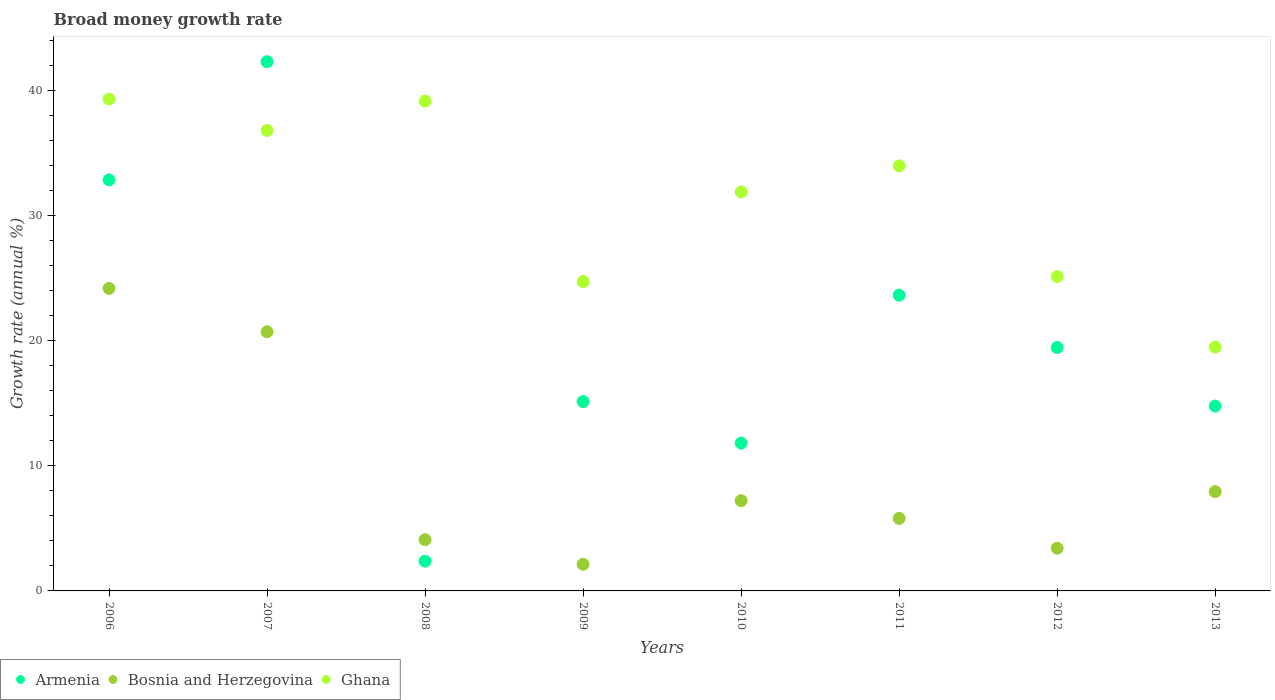How many different coloured dotlines are there?
Ensure brevity in your answer.  3. What is the growth rate in Ghana in 2010?
Your response must be concise. 31.92. Across all years, what is the maximum growth rate in Bosnia and Herzegovina?
Offer a very short reply. 24.2. Across all years, what is the minimum growth rate in Ghana?
Provide a short and direct response. 19.5. In which year was the growth rate in Armenia maximum?
Keep it short and to the point. 2007. What is the total growth rate in Bosnia and Herzegovina in the graph?
Make the answer very short. 75.53. What is the difference between the growth rate in Ghana in 2008 and that in 2013?
Your answer should be very brief. 19.68. What is the difference between the growth rate in Bosnia and Herzegovina in 2011 and the growth rate in Armenia in 2009?
Your answer should be very brief. -9.35. What is the average growth rate in Bosnia and Herzegovina per year?
Make the answer very short. 9.44. In the year 2010, what is the difference between the growth rate in Bosnia and Herzegovina and growth rate in Armenia?
Your response must be concise. -4.61. What is the ratio of the growth rate in Armenia in 2006 to that in 2013?
Offer a terse response. 2.22. Is the growth rate in Armenia in 2006 less than that in 2009?
Your response must be concise. No. What is the difference between the highest and the second highest growth rate in Bosnia and Herzegovina?
Make the answer very short. 3.47. What is the difference between the highest and the lowest growth rate in Bosnia and Herzegovina?
Ensure brevity in your answer.  22.07. Is the sum of the growth rate in Ghana in 2009 and 2011 greater than the maximum growth rate in Bosnia and Herzegovina across all years?
Your answer should be compact. Yes. Is it the case that in every year, the sum of the growth rate in Armenia and growth rate in Ghana  is greater than the growth rate in Bosnia and Herzegovina?
Your answer should be very brief. Yes. Is the growth rate in Armenia strictly greater than the growth rate in Bosnia and Herzegovina over the years?
Make the answer very short. No. How many years are there in the graph?
Offer a terse response. 8. What is the difference between two consecutive major ticks on the Y-axis?
Provide a succinct answer. 10. Where does the legend appear in the graph?
Ensure brevity in your answer.  Bottom left. How are the legend labels stacked?
Provide a succinct answer. Horizontal. What is the title of the graph?
Give a very brief answer. Broad money growth rate. Does "Grenada" appear as one of the legend labels in the graph?
Ensure brevity in your answer.  No. What is the label or title of the Y-axis?
Your answer should be compact. Growth rate (annual %). What is the Growth rate (annual %) of Armenia in 2006?
Provide a short and direct response. 32.88. What is the Growth rate (annual %) of Bosnia and Herzegovina in 2006?
Your answer should be very brief. 24.2. What is the Growth rate (annual %) of Ghana in 2006?
Give a very brief answer. 39.34. What is the Growth rate (annual %) in Armenia in 2007?
Provide a succinct answer. 42.33. What is the Growth rate (annual %) in Bosnia and Herzegovina in 2007?
Ensure brevity in your answer.  20.72. What is the Growth rate (annual %) in Ghana in 2007?
Offer a terse response. 36.83. What is the Growth rate (annual %) of Armenia in 2008?
Your answer should be very brief. 2.38. What is the Growth rate (annual %) of Bosnia and Herzegovina in 2008?
Your answer should be compact. 4.1. What is the Growth rate (annual %) in Ghana in 2008?
Give a very brief answer. 39.18. What is the Growth rate (annual %) in Armenia in 2009?
Your response must be concise. 15.15. What is the Growth rate (annual %) of Bosnia and Herzegovina in 2009?
Your response must be concise. 2.13. What is the Growth rate (annual %) of Ghana in 2009?
Give a very brief answer. 24.74. What is the Growth rate (annual %) of Armenia in 2010?
Keep it short and to the point. 11.83. What is the Growth rate (annual %) in Bosnia and Herzegovina in 2010?
Keep it short and to the point. 7.22. What is the Growth rate (annual %) in Ghana in 2010?
Make the answer very short. 31.92. What is the Growth rate (annual %) of Armenia in 2011?
Offer a terse response. 23.66. What is the Growth rate (annual %) in Bosnia and Herzegovina in 2011?
Your answer should be compact. 5.8. What is the Growth rate (annual %) of Ghana in 2011?
Keep it short and to the point. 33.99. What is the Growth rate (annual %) in Armenia in 2012?
Provide a short and direct response. 19.47. What is the Growth rate (annual %) of Bosnia and Herzegovina in 2012?
Provide a short and direct response. 3.41. What is the Growth rate (annual %) of Ghana in 2012?
Give a very brief answer. 25.14. What is the Growth rate (annual %) of Armenia in 2013?
Your answer should be compact. 14.78. What is the Growth rate (annual %) of Bosnia and Herzegovina in 2013?
Your response must be concise. 7.94. What is the Growth rate (annual %) in Ghana in 2013?
Your answer should be compact. 19.5. Across all years, what is the maximum Growth rate (annual %) of Armenia?
Provide a succinct answer. 42.33. Across all years, what is the maximum Growth rate (annual %) in Bosnia and Herzegovina?
Give a very brief answer. 24.2. Across all years, what is the maximum Growth rate (annual %) of Ghana?
Make the answer very short. 39.34. Across all years, what is the minimum Growth rate (annual %) of Armenia?
Give a very brief answer. 2.38. Across all years, what is the minimum Growth rate (annual %) of Bosnia and Herzegovina?
Ensure brevity in your answer.  2.13. Across all years, what is the minimum Growth rate (annual %) in Ghana?
Ensure brevity in your answer.  19.5. What is the total Growth rate (annual %) of Armenia in the graph?
Your response must be concise. 162.46. What is the total Growth rate (annual %) in Bosnia and Herzegovina in the graph?
Give a very brief answer. 75.53. What is the total Growth rate (annual %) of Ghana in the graph?
Your answer should be very brief. 250.64. What is the difference between the Growth rate (annual %) of Armenia in 2006 and that in 2007?
Make the answer very short. -9.45. What is the difference between the Growth rate (annual %) of Bosnia and Herzegovina in 2006 and that in 2007?
Provide a succinct answer. 3.47. What is the difference between the Growth rate (annual %) of Ghana in 2006 and that in 2007?
Your response must be concise. 2.51. What is the difference between the Growth rate (annual %) in Armenia in 2006 and that in 2008?
Your response must be concise. 30.5. What is the difference between the Growth rate (annual %) in Bosnia and Herzegovina in 2006 and that in 2008?
Your response must be concise. 20.1. What is the difference between the Growth rate (annual %) of Ghana in 2006 and that in 2008?
Offer a very short reply. 0.16. What is the difference between the Growth rate (annual %) of Armenia in 2006 and that in 2009?
Your response must be concise. 17.73. What is the difference between the Growth rate (annual %) of Bosnia and Herzegovina in 2006 and that in 2009?
Provide a succinct answer. 22.07. What is the difference between the Growth rate (annual %) of Ghana in 2006 and that in 2009?
Ensure brevity in your answer.  14.6. What is the difference between the Growth rate (annual %) in Armenia in 2006 and that in 2010?
Offer a very short reply. 21.05. What is the difference between the Growth rate (annual %) in Bosnia and Herzegovina in 2006 and that in 2010?
Your answer should be compact. 16.98. What is the difference between the Growth rate (annual %) in Ghana in 2006 and that in 2010?
Your answer should be very brief. 7.42. What is the difference between the Growth rate (annual %) in Armenia in 2006 and that in 2011?
Your response must be concise. 9.22. What is the difference between the Growth rate (annual %) in Bosnia and Herzegovina in 2006 and that in 2011?
Keep it short and to the point. 18.4. What is the difference between the Growth rate (annual %) of Ghana in 2006 and that in 2011?
Keep it short and to the point. 5.35. What is the difference between the Growth rate (annual %) of Armenia in 2006 and that in 2012?
Offer a terse response. 13.41. What is the difference between the Growth rate (annual %) of Bosnia and Herzegovina in 2006 and that in 2012?
Offer a terse response. 20.78. What is the difference between the Growth rate (annual %) in Ghana in 2006 and that in 2012?
Make the answer very short. 14.2. What is the difference between the Growth rate (annual %) in Armenia in 2006 and that in 2013?
Keep it short and to the point. 18.1. What is the difference between the Growth rate (annual %) of Bosnia and Herzegovina in 2006 and that in 2013?
Give a very brief answer. 16.26. What is the difference between the Growth rate (annual %) in Ghana in 2006 and that in 2013?
Ensure brevity in your answer.  19.84. What is the difference between the Growth rate (annual %) of Armenia in 2007 and that in 2008?
Your answer should be very brief. 39.95. What is the difference between the Growth rate (annual %) of Bosnia and Herzegovina in 2007 and that in 2008?
Your response must be concise. 16.62. What is the difference between the Growth rate (annual %) in Ghana in 2007 and that in 2008?
Your response must be concise. -2.34. What is the difference between the Growth rate (annual %) of Armenia in 2007 and that in 2009?
Offer a very short reply. 27.18. What is the difference between the Growth rate (annual %) of Bosnia and Herzegovina in 2007 and that in 2009?
Offer a terse response. 18.59. What is the difference between the Growth rate (annual %) of Ghana in 2007 and that in 2009?
Provide a succinct answer. 12.1. What is the difference between the Growth rate (annual %) of Armenia in 2007 and that in 2010?
Keep it short and to the point. 30.5. What is the difference between the Growth rate (annual %) in Bosnia and Herzegovina in 2007 and that in 2010?
Your answer should be compact. 13.51. What is the difference between the Growth rate (annual %) of Ghana in 2007 and that in 2010?
Provide a succinct answer. 4.92. What is the difference between the Growth rate (annual %) in Armenia in 2007 and that in 2011?
Your answer should be compact. 18.67. What is the difference between the Growth rate (annual %) of Bosnia and Herzegovina in 2007 and that in 2011?
Offer a terse response. 14.93. What is the difference between the Growth rate (annual %) in Ghana in 2007 and that in 2011?
Offer a terse response. 2.84. What is the difference between the Growth rate (annual %) of Armenia in 2007 and that in 2012?
Offer a very short reply. 22.86. What is the difference between the Growth rate (annual %) of Bosnia and Herzegovina in 2007 and that in 2012?
Make the answer very short. 17.31. What is the difference between the Growth rate (annual %) in Ghana in 2007 and that in 2012?
Provide a succinct answer. 11.7. What is the difference between the Growth rate (annual %) of Armenia in 2007 and that in 2013?
Provide a succinct answer. 27.55. What is the difference between the Growth rate (annual %) of Bosnia and Herzegovina in 2007 and that in 2013?
Offer a terse response. 12.78. What is the difference between the Growth rate (annual %) of Ghana in 2007 and that in 2013?
Offer a terse response. 17.33. What is the difference between the Growth rate (annual %) of Armenia in 2008 and that in 2009?
Your answer should be compact. -12.77. What is the difference between the Growth rate (annual %) of Bosnia and Herzegovina in 2008 and that in 2009?
Provide a short and direct response. 1.97. What is the difference between the Growth rate (annual %) in Ghana in 2008 and that in 2009?
Give a very brief answer. 14.44. What is the difference between the Growth rate (annual %) in Armenia in 2008 and that in 2010?
Ensure brevity in your answer.  -9.45. What is the difference between the Growth rate (annual %) of Bosnia and Herzegovina in 2008 and that in 2010?
Your response must be concise. -3.12. What is the difference between the Growth rate (annual %) of Ghana in 2008 and that in 2010?
Make the answer very short. 7.26. What is the difference between the Growth rate (annual %) of Armenia in 2008 and that in 2011?
Your answer should be very brief. -21.28. What is the difference between the Growth rate (annual %) of Bosnia and Herzegovina in 2008 and that in 2011?
Your response must be concise. -1.7. What is the difference between the Growth rate (annual %) in Ghana in 2008 and that in 2011?
Your answer should be compact. 5.18. What is the difference between the Growth rate (annual %) of Armenia in 2008 and that in 2012?
Offer a terse response. -17.09. What is the difference between the Growth rate (annual %) of Bosnia and Herzegovina in 2008 and that in 2012?
Your response must be concise. 0.69. What is the difference between the Growth rate (annual %) of Ghana in 2008 and that in 2012?
Offer a terse response. 14.04. What is the difference between the Growth rate (annual %) in Armenia in 2008 and that in 2013?
Offer a very short reply. -12.4. What is the difference between the Growth rate (annual %) of Bosnia and Herzegovina in 2008 and that in 2013?
Provide a short and direct response. -3.84. What is the difference between the Growth rate (annual %) of Ghana in 2008 and that in 2013?
Keep it short and to the point. 19.68. What is the difference between the Growth rate (annual %) of Armenia in 2009 and that in 2010?
Keep it short and to the point. 3.32. What is the difference between the Growth rate (annual %) of Bosnia and Herzegovina in 2009 and that in 2010?
Provide a succinct answer. -5.09. What is the difference between the Growth rate (annual %) in Ghana in 2009 and that in 2010?
Make the answer very short. -7.18. What is the difference between the Growth rate (annual %) in Armenia in 2009 and that in 2011?
Your answer should be very brief. -8.51. What is the difference between the Growth rate (annual %) of Bosnia and Herzegovina in 2009 and that in 2011?
Offer a terse response. -3.67. What is the difference between the Growth rate (annual %) of Ghana in 2009 and that in 2011?
Provide a succinct answer. -9.26. What is the difference between the Growth rate (annual %) of Armenia in 2009 and that in 2012?
Keep it short and to the point. -4.32. What is the difference between the Growth rate (annual %) of Bosnia and Herzegovina in 2009 and that in 2012?
Offer a very short reply. -1.28. What is the difference between the Growth rate (annual %) of Ghana in 2009 and that in 2012?
Give a very brief answer. -0.4. What is the difference between the Growth rate (annual %) of Armenia in 2009 and that in 2013?
Your answer should be very brief. 0.36. What is the difference between the Growth rate (annual %) of Bosnia and Herzegovina in 2009 and that in 2013?
Provide a succinct answer. -5.81. What is the difference between the Growth rate (annual %) of Ghana in 2009 and that in 2013?
Your response must be concise. 5.24. What is the difference between the Growth rate (annual %) of Armenia in 2010 and that in 2011?
Keep it short and to the point. -11.83. What is the difference between the Growth rate (annual %) of Bosnia and Herzegovina in 2010 and that in 2011?
Provide a succinct answer. 1.42. What is the difference between the Growth rate (annual %) in Ghana in 2010 and that in 2011?
Give a very brief answer. -2.08. What is the difference between the Growth rate (annual %) of Armenia in 2010 and that in 2012?
Your answer should be very brief. -7.64. What is the difference between the Growth rate (annual %) in Bosnia and Herzegovina in 2010 and that in 2012?
Your response must be concise. 3.8. What is the difference between the Growth rate (annual %) of Ghana in 2010 and that in 2012?
Offer a terse response. 6.78. What is the difference between the Growth rate (annual %) in Armenia in 2010 and that in 2013?
Give a very brief answer. -2.95. What is the difference between the Growth rate (annual %) of Bosnia and Herzegovina in 2010 and that in 2013?
Your answer should be compact. -0.72. What is the difference between the Growth rate (annual %) of Ghana in 2010 and that in 2013?
Provide a short and direct response. 12.42. What is the difference between the Growth rate (annual %) in Armenia in 2011 and that in 2012?
Your answer should be compact. 4.19. What is the difference between the Growth rate (annual %) in Bosnia and Herzegovina in 2011 and that in 2012?
Ensure brevity in your answer.  2.38. What is the difference between the Growth rate (annual %) of Ghana in 2011 and that in 2012?
Your answer should be very brief. 8.86. What is the difference between the Growth rate (annual %) of Armenia in 2011 and that in 2013?
Your answer should be compact. 8.87. What is the difference between the Growth rate (annual %) in Bosnia and Herzegovina in 2011 and that in 2013?
Provide a succinct answer. -2.14. What is the difference between the Growth rate (annual %) of Ghana in 2011 and that in 2013?
Offer a very short reply. 14.49. What is the difference between the Growth rate (annual %) in Armenia in 2012 and that in 2013?
Your answer should be very brief. 4.69. What is the difference between the Growth rate (annual %) of Bosnia and Herzegovina in 2012 and that in 2013?
Offer a terse response. -4.53. What is the difference between the Growth rate (annual %) of Ghana in 2012 and that in 2013?
Provide a succinct answer. 5.64. What is the difference between the Growth rate (annual %) in Armenia in 2006 and the Growth rate (annual %) in Bosnia and Herzegovina in 2007?
Your answer should be compact. 12.15. What is the difference between the Growth rate (annual %) of Armenia in 2006 and the Growth rate (annual %) of Ghana in 2007?
Keep it short and to the point. -3.96. What is the difference between the Growth rate (annual %) in Bosnia and Herzegovina in 2006 and the Growth rate (annual %) in Ghana in 2007?
Your answer should be very brief. -12.64. What is the difference between the Growth rate (annual %) in Armenia in 2006 and the Growth rate (annual %) in Bosnia and Herzegovina in 2008?
Your answer should be compact. 28.78. What is the difference between the Growth rate (annual %) of Armenia in 2006 and the Growth rate (annual %) of Ghana in 2008?
Offer a terse response. -6.3. What is the difference between the Growth rate (annual %) in Bosnia and Herzegovina in 2006 and the Growth rate (annual %) in Ghana in 2008?
Your answer should be compact. -14.98. What is the difference between the Growth rate (annual %) in Armenia in 2006 and the Growth rate (annual %) in Bosnia and Herzegovina in 2009?
Keep it short and to the point. 30.75. What is the difference between the Growth rate (annual %) of Armenia in 2006 and the Growth rate (annual %) of Ghana in 2009?
Give a very brief answer. 8.14. What is the difference between the Growth rate (annual %) in Bosnia and Herzegovina in 2006 and the Growth rate (annual %) in Ghana in 2009?
Keep it short and to the point. -0.54. What is the difference between the Growth rate (annual %) of Armenia in 2006 and the Growth rate (annual %) of Bosnia and Herzegovina in 2010?
Your answer should be very brief. 25.66. What is the difference between the Growth rate (annual %) of Armenia in 2006 and the Growth rate (annual %) of Ghana in 2010?
Give a very brief answer. 0.96. What is the difference between the Growth rate (annual %) of Bosnia and Herzegovina in 2006 and the Growth rate (annual %) of Ghana in 2010?
Provide a succinct answer. -7.72. What is the difference between the Growth rate (annual %) of Armenia in 2006 and the Growth rate (annual %) of Bosnia and Herzegovina in 2011?
Your answer should be compact. 27.08. What is the difference between the Growth rate (annual %) of Armenia in 2006 and the Growth rate (annual %) of Ghana in 2011?
Keep it short and to the point. -1.12. What is the difference between the Growth rate (annual %) of Bosnia and Herzegovina in 2006 and the Growth rate (annual %) of Ghana in 2011?
Give a very brief answer. -9.8. What is the difference between the Growth rate (annual %) of Armenia in 2006 and the Growth rate (annual %) of Bosnia and Herzegovina in 2012?
Give a very brief answer. 29.46. What is the difference between the Growth rate (annual %) in Armenia in 2006 and the Growth rate (annual %) in Ghana in 2012?
Provide a succinct answer. 7.74. What is the difference between the Growth rate (annual %) in Bosnia and Herzegovina in 2006 and the Growth rate (annual %) in Ghana in 2012?
Make the answer very short. -0.94. What is the difference between the Growth rate (annual %) in Armenia in 2006 and the Growth rate (annual %) in Bosnia and Herzegovina in 2013?
Your answer should be compact. 24.94. What is the difference between the Growth rate (annual %) in Armenia in 2006 and the Growth rate (annual %) in Ghana in 2013?
Provide a short and direct response. 13.38. What is the difference between the Growth rate (annual %) in Bosnia and Herzegovina in 2006 and the Growth rate (annual %) in Ghana in 2013?
Offer a very short reply. 4.7. What is the difference between the Growth rate (annual %) of Armenia in 2007 and the Growth rate (annual %) of Bosnia and Herzegovina in 2008?
Your answer should be compact. 38.23. What is the difference between the Growth rate (annual %) in Armenia in 2007 and the Growth rate (annual %) in Ghana in 2008?
Offer a very short reply. 3.15. What is the difference between the Growth rate (annual %) in Bosnia and Herzegovina in 2007 and the Growth rate (annual %) in Ghana in 2008?
Your response must be concise. -18.45. What is the difference between the Growth rate (annual %) of Armenia in 2007 and the Growth rate (annual %) of Bosnia and Herzegovina in 2009?
Your response must be concise. 40.2. What is the difference between the Growth rate (annual %) in Armenia in 2007 and the Growth rate (annual %) in Ghana in 2009?
Offer a very short reply. 17.59. What is the difference between the Growth rate (annual %) of Bosnia and Herzegovina in 2007 and the Growth rate (annual %) of Ghana in 2009?
Your answer should be compact. -4.01. What is the difference between the Growth rate (annual %) in Armenia in 2007 and the Growth rate (annual %) in Bosnia and Herzegovina in 2010?
Keep it short and to the point. 35.11. What is the difference between the Growth rate (annual %) of Armenia in 2007 and the Growth rate (annual %) of Ghana in 2010?
Your response must be concise. 10.41. What is the difference between the Growth rate (annual %) of Bosnia and Herzegovina in 2007 and the Growth rate (annual %) of Ghana in 2010?
Your answer should be compact. -11.19. What is the difference between the Growth rate (annual %) in Armenia in 2007 and the Growth rate (annual %) in Bosnia and Herzegovina in 2011?
Offer a very short reply. 36.53. What is the difference between the Growth rate (annual %) in Armenia in 2007 and the Growth rate (annual %) in Ghana in 2011?
Provide a short and direct response. 8.33. What is the difference between the Growth rate (annual %) of Bosnia and Herzegovina in 2007 and the Growth rate (annual %) of Ghana in 2011?
Offer a terse response. -13.27. What is the difference between the Growth rate (annual %) in Armenia in 2007 and the Growth rate (annual %) in Bosnia and Herzegovina in 2012?
Ensure brevity in your answer.  38.91. What is the difference between the Growth rate (annual %) in Armenia in 2007 and the Growth rate (annual %) in Ghana in 2012?
Keep it short and to the point. 17.19. What is the difference between the Growth rate (annual %) in Bosnia and Herzegovina in 2007 and the Growth rate (annual %) in Ghana in 2012?
Provide a short and direct response. -4.41. What is the difference between the Growth rate (annual %) in Armenia in 2007 and the Growth rate (annual %) in Bosnia and Herzegovina in 2013?
Your answer should be compact. 34.39. What is the difference between the Growth rate (annual %) of Armenia in 2007 and the Growth rate (annual %) of Ghana in 2013?
Provide a short and direct response. 22.83. What is the difference between the Growth rate (annual %) of Bosnia and Herzegovina in 2007 and the Growth rate (annual %) of Ghana in 2013?
Provide a succinct answer. 1.22. What is the difference between the Growth rate (annual %) of Armenia in 2008 and the Growth rate (annual %) of Bosnia and Herzegovina in 2009?
Make the answer very short. 0.25. What is the difference between the Growth rate (annual %) of Armenia in 2008 and the Growth rate (annual %) of Ghana in 2009?
Give a very brief answer. -22.36. What is the difference between the Growth rate (annual %) in Bosnia and Herzegovina in 2008 and the Growth rate (annual %) in Ghana in 2009?
Give a very brief answer. -20.64. What is the difference between the Growth rate (annual %) in Armenia in 2008 and the Growth rate (annual %) in Bosnia and Herzegovina in 2010?
Your response must be concise. -4.84. What is the difference between the Growth rate (annual %) of Armenia in 2008 and the Growth rate (annual %) of Ghana in 2010?
Keep it short and to the point. -29.54. What is the difference between the Growth rate (annual %) in Bosnia and Herzegovina in 2008 and the Growth rate (annual %) in Ghana in 2010?
Your response must be concise. -27.82. What is the difference between the Growth rate (annual %) of Armenia in 2008 and the Growth rate (annual %) of Bosnia and Herzegovina in 2011?
Offer a terse response. -3.42. What is the difference between the Growth rate (annual %) of Armenia in 2008 and the Growth rate (annual %) of Ghana in 2011?
Give a very brief answer. -31.62. What is the difference between the Growth rate (annual %) in Bosnia and Herzegovina in 2008 and the Growth rate (annual %) in Ghana in 2011?
Provide a succinct answer. -29.89. What is the difference between the Growth rate (annual %) of Armenia in 2008 and the Growth rate (annual %) of Bosnia and Herzegovina in 2012?
Your response must be concise. -1.04. What is the difference between the Growth rate (annual %) in Armenia in 2008 and the Growth rate (annual %) in Ghana in 2012?
Your response must be concise. -22.76. What is the difference between the Growth rate (annual %) of Bosnia and Herzegovina in 2008 and the Growth rate (annual %) of Ghana in 2012?
Ensure brevity in your answer.  -21.04. What is the difference between the Growth rate (annual %) of Armenia in 2008 and the Growth rate (annual %) of Bosnia and Herzegovina in 2013?
Your answer should be compact. -5.56. What is the difference between the Growth rate (annual %) of Armenia in 2008 and the Growth rate (annual %) of Ghana in 2013?
Provide a succinct answer. -17.12. What is the difference between the Growth rate (annual %) of Bosnia and Herzegovina in 2008 and the Growth rate (annual %) of Ghana in 2013?
Provide a succinct answer. -15.4. What is the difference between the Growth rate (annual %) in Armenia in 2009 and the Growth rate (annual %) in Bosnia and Herzegovina in 2010?
Provide a succinct answer. 7.93. What is the difference between the Growth rate (annual %) of Armenia in 2009 and the Growth rate (annual %) of Ghana in 2010?
Provide a short and direct response. -16.77. What is the difference between the Growth rate (annual %) in Bosnia and Herzegovina in 2009 and the Growth rate (annual %) in Ghana in 2010?
Your answer should be compact. -29.79. What is the difference between the Growth rate (annual %) in Armenia in 2009 and the Growth rate (annual %) in Bosnia and Herzegovina in 2011?
Provide a succinct answer. 9.35. What is the difference between the Growth rate (annual %) in Armenia in 2009 and the Growth rate (annual %) in Ghana in 2011?
Make the answer very short. -18.85. What is the difference between the Growth rate (annual %) of Bosnia and Herzegovina in 2009 and the Growth rate (annual %) of Ghana in 2011?
Your answer should be compact. -31.86. What is the difference between the Growth rate (annual %) in Armenia in 2009 and the Growth rate (annual %) in Bosnia and Herzegovina in 2012?
Offer a very short reply. 11.73. What is the difference between the Growth rate (annual %) of Armenia in 2009 and the Growth rate (annual %) of Ghana in 2012?
Your response must be concise. -9.99. What is the difference between the Growth rate (annual %) in Bosnia and Herzegovina in 2009 and the Growth rate (annual %) in Ghana in 2012?
Give a very brief answer. -23.01. What is the difference between the Growth rate (annual %) in Armenia in 2009 and the Growth rate (annual %) in Bosnia and Herzegovina in 2013?
Provide a short and direct response. 7.21. What is the difference between the Growth rate (annual %) of Armenia in 2009 and the Growth rate (annual %) of Ghana in 2013?
Make the answer very short. -4.35. What is the difference between the Growth rate (annual %) in Bosnia and Herzegovina in 2009 and the Growth rate (annual %) in Ghana in 2013?
Offer a terse response. -17.37. What is the difference between the Growth rate (annual %) of Armenia in 2010 and the Growth rate (annual %) of Bosnia and Herzegovina in 2011?
Your response must be concise. 6.03. What is the difference between the Growth rate (annual %) of Armenia in 2010 and the Growth rate (annual %) of Ghana in 2011?
Your answer should be very brief. -22.17. What is the difference between the Growth rate (annual %) of Bosnia and Herzegovina in 2010 and the Growth rate (annual %) of Ghana in 2011?
Your response must be concise. -26.78. What is the difference between the Growth rate (annual %) of Armenia in 2010 and the Growth rate (annual %) of Bosnia and Herzegovina in 2012?
Give a very brief answer. 8.41. What is the difference between the Growth rate (annual %) of Armenia in 2010 and the Growth rate (annual %) of Ghana in 2012?
Provide a succinct answer. -13.31. What is the difference between the Growth rate (annual %) of Bosnia and Herzegovina in 2010 and the Growth rate (annual %) of Ghana in 2012?
Give a very brief answer. -17.92. What is the difference between the Growth rate (annual %) in Armenia in 2010 and the Growth rate (annual %) in Bosnia and Herzegovina in 2013?
Keep it short and to the point. 3.89. What is the difference between the Growth rate (annual %) in Armenia in 2010 and the Growth rate (annual %) in Ghana in 2013?
Keep it short and to the point. -7.67. What is the difference between the Growth rate (annual %) of Bosnia and Herzegovina in 2010 and the Growth rate (annual %) of Ghana in 2013?
Keep it short and to the point. -12.28. What is the difference between the Growth rate (annual %) of Armenia in 2011 and the Growth rate (annual %) of Bosnia and Herzegovina in 2012?
Ensure brevity in your answer.  20.24. What is the difference between the Growth rate (annual %) in Armenia in 2011 and the Growth rate (annual %) in Ghana in 2012?
Offer a terse response. -1.48. What is the difference between the Growth rate (annual %) of Bosnia and Herzegovina in 2011 and the Growth rate (annual %) of Ghana in 2012?
Offer a terse response. -19.34. What is the difference between the Growth rate (annual %) in Armenia in 2011 and the Growth rate (annual %) in Bosnia and Herzegovina in 2013?
Offer a very short reply. 15.72. What is the difference between the Growth rate (annual %) in Armenia in 2011 and the Growth rate (annual %) in Ghana in 2013?
Provide a short and direct response. 4.15. What is the difference between the Growth rate (annual %) of Bosnia and Herzegovina in 2011 and the Growth rate (annual %) of Ghana in 2013?
Ensure brevity in your answer.  -13.7. What is the difference between the Growth rate (annual %) of Armenia in 2012 and the Growth rate (annual %) of Bosnia and Herzegovina in 2013?
Provide a short and direct response. 11.53. What is the difference between the Growth rate (annual %) in Armenia in 2012 and the Growth rate (annual %) in Ghana in 2013?
Your response must be concise. -0.03. What is the difference between the Growth rate (annual %) of Bosnia and Herzegovina in 2012 and the Growth rate (annual %) of Ghana in 2013?
Your answer should be very brief. -16.09. What is the average Growth rate (annual %) in Armenia per year?
Provide a short and direct response. 20.31. What is the average Growth rate (annual %) of Bosnia and Herzegovina per year?
Offer a terse response. 9.44. What is the average Growth rate (annual %) in Ghana per year?
Keep it short and to the point. 31.33. In the year 2006, what is the difference between the Growth rate (annual %) of Armenia and Growth rate (annual %) of Bosnia and Herzegovina?
Your response must be concise. 8.68. In the year 2006, what is the difference between the Growth rate (annual %) in Armenia and Growth rate (annual %) in Ghana?
Offer a very short reply. -6.46. In the year 2006, what is the difference between the Growth rate (annual %) in Bosnia and Herzegovina and Growth rate (annual %) in Ghana?
Make the answer very short. -15.14. In the year 2007, what is the difference between the Growth rate (annual %) of Armenia and Growth rate (annual %) of Bosnia and Herzegovina?
Your response must be concise. 21.6. In the year 2007, what is the difference between the Growth rate (annual %) in Armenia and Growth rate (annual %) in Ghana?
Offer a very short reply. 5.49. In the year 2007, what is the difference between the Growth rate (annual %) of Bosnia and Herzegovina and Growth rate (annual %) of Ghana?
Provide a succinct answer. -16.11. In the year 2008, what is the difference between the Growth rate (annual %) in Armenia and Growth rate (annual %) in Bosnia and Herzegovina?
Your answer should be compact. -1.72. In the year 2008, what is the difference between the Growth rate (annual %) in Armenia and Growth rate (annual %) in Ghana?
Offer a very short reply. -36.8. In the year 2008, what is the difference between the Growth rate (annual %) in Bosnia and Herzegovina and Growth rate (annual %) in Ghana?
Give a very brief answer. -35.08. In the year 2009, what is the difference between the Growth rate (annual %) in Armenia and Growth rate (annual %) in Bosnia and Herzegovina?
Provide a short and direct response. 13.01. In the year 2009, what is the difference between the Growth rate (annual %) in Armenia and Growth rate (annual %) in Ghana?
Your answer should be compact. -9.59. In the year 2009, what is the difference between the Growth rate (annual %) of Bosnia and Herzegovina and Growth rate (annual %) of Ghana?
Provide a short and direct response. -22.61. In the year 2010, what is the difference between the Growth rate (annual %) of Armenia and Growth rate (annual %) of Bosnia and Herzegovina?
Your response must be concise. 4.61. In the year 2010, what is the difference between the Growth rate (annual %) in Armenia and Growth rate (annual %) in Ghana?
Your response must be concise. -20.09. In the year 2010, what is the difference between the Growth rate (annual %) in Bosnia and Herzegovina and Growth rate (annual %) in Ghana?
Provide a short and direct response. -24.7. In the year 2011, what is the difference between the Growth rate (annual %) of Armenia and Growth rate (annual %) of Bosnia and Herzegovina?
Keep it short and to the point. 17.86. In the year 2011, what is the difference between the Growth rate (annual %) of Armenia and Growth rate (annual %) of Ghana?
Provide a short and direct response. -10.34. In the year 2011, what is the difference between the Growth rate (annual %) in Bosnia and Herzegovina and Growth rate (annual %) in Ghana?
Give a very brief answer. -28.2. In the year 2012, what is the difference between the Growth rate (annual %) in Armenia and Growth rate (annual %) in Bosnia and Herzegovina?
Provide a short and direct response. 16.05. In the year 2012, what is the difference between the Growth rate (annual %) of Armenia and Growth rate (annual %) of Ghana?
Offer a terse response. -5.67. In the year 2012, what is the difference between the Growth rate (annual %) in Bosnia and Herzegovina and Growth rate (annual %) in Ghana?
Ensure brevity in your answer.  -21.72. In the year 2013, what is the difference between the Growth rate (annual %) in Armenia and Growth rate (annual %) in Bosnia and Herzegovina?
Give a very brief answer. 6.84. In the year 2013, what is the difference between the Growth rate (annual %) in Armenia and Growth rate (annual %) in Ghana?
Provide a succinct answer. -4.72. In the year 2013, what is the difference between the Growth rate (annual %) of Bosnia and Herzegovina and Growth rate (annual %) of Ghana?
Offer a very short reply. -11.56. What is the ratio of the Growth rate (annual %) in Armenia in 2006 to that in 2007?
Your answer should be very brief. 0.78. What is the ratio of the Growth rate (annual %) of Bosnia and Herzegovina in 2006 to that in 2007?
Offer a terse response. 1.17. What is the ratio of the Growth rate (annual %) in Ghana in 2006 to that in 2007?
Offer a very short reply. 1.07. What is the ratio of the Growth rate (annual %) of Armenia in 2006 to that in 2008?
Offer a terse response. 13.82. What is the ratio of the Growth rate (annual %) in Bosnia and Herzegovina in 2006 to that in 2008?
Offer a terse response. 5.9. What is the ratio of the Growth rate (annual %) in Ghana in 2006 to that in 2008?
Your answer should be compact. 1. What is the ratio of the Growth rate (annual %) in Armenia in 2006 to that in 2009?
Your answer should be very brief. 2.17. What is the ratio of the Growth rate (annual %) of Bosnia and Herzegovina in 2006 to that in 2009?
Your answer should be very brief. 11.35. What is the ratio of the Growth rate (annual %) of Ghana in 2006 to that in 2009?
Give a very brief answer. 1.59. What is the ratio of the Growth rate (annual %) in Armenia in 2006 to that in 2010?
Offer a terse response. 2.78. What is the ratio of the Growth rate (annual %) of Bosnia and Herzegovina in 2006 to that in 2010?
Provide a succinct answer. 3.35. What is the ratio of the Growth rate (annual %) in Ghana in 2006 to that in 2010?
Offer a terse response. 1.23. What is the ratio of the Growth rate (annual %) in Armenia in 2006 to that in 2011?
Provide a succinct answer. 1.39. What is the ratio of the Growth rate (annual %) in Bosnia and Herzegovina in 2006 to that in 2011?
Offer a terse response. 4.17. What is the ratio of the Growth rate (annual %) in Ghana in 2006 to that in 2011?
Your response must be concise. 1.16. What is the ratio of the Growth rate (annual %) in Armenia in 2006 to that in 2012?
Provide a succinct answer. 1.69. What is the ratio of the Growth rate (annual %) of Bosnia and Herzegovina in 2006 to that in 2012?
Offer a terse response. 7.09. What is the ratio of the Growth rate (annual %) in Ghana in 2006 to that in 2012?
Keep it short and to the point. 1.56. What is the ratio of the Growth rate (annual %) in Armenia in 2006 to that in 2013?
Offer a terse response. 2.22. What is the ratio of the Growth rate (annual %) in Bosnia and Herzegovina in 2006 to that in 2013?
Give a very brief answer. 3.05. What is the ratio of the Growth rate (annual %) of Ghana in 2006 to that in 2013?
Your response must be concise. 2.02. What is the ratio of the Growth rate (annual %) of Armenia in 2007 to that in 2008?
Give a very brief answer. 17.8. What is the ratio of the Growth rate (annual %) in Bosnia and Herzegovina in 2007 to that in 2008?
Your response must be concise. 5.05. What is the ratio of the Growth rate (annual %) of Ghana in 2007 to that in 2008?
Keep it short and to the point. 0.94. What is the ratio of the Growth rate (annual %) in Armenia in 2007 to that in 2009?
Make the answer very short. 2.79. What is the ratio of the Growth rate (annual %) of Bosnia and Herzegovina in 2007 to that in 2009?
Give a very brief answer. 9.72. What is the ratio of the Growth rate (annual %) of Ghana in 2007 to that in 2009?
Make the answer very short. 1.49. What is the ratio of the Growth rate (annual %) in Armenia in 2007 to that in 2010?
Provide a short and direct response. 3.58. What is the ratio of the Growth rate (annual %) in Bosnia and Herzegovina in 2007 to that in 2010?
Ensure brevity in your answer.  2.87. What is the ratio of the Growth rate (annual %) of Ghana in 2007 to that in 2010?
Your response must be concise. 1.15. What is the ratio of the Growth rate (annual %) of Armenia in 2007 to that in 2011?
Make the answer very short. 1.79. What is the ratio of the Growth rate (annual %) of Bosnia and Herzegovina in 2007 to that in 2011?
Offer a very short reply. 3.57. What is the ratio of the Growth rate (annual %) in Ghana in 2007 to that in 2011?
Keep it short and to the point. 1.08. What is the ratio of the Growth rate (annual %) of Armenia in 2007 to that in 2012?
Give a very brief answer. 2.17. What is the ratio of the Growth rate (annual %) in Bosnia and Herzegovina in 2007 to that in 2012?
Give a very brief answer. 6.07. What is the ratio of the Growth rate (annual %) in Ghana in 2007 to that in 2012?
Ensure brevity in your answer.  1.47. What is the ratio of the Growth rate (annual %) of Armenia in 2007 to that in 2013?
Your response must be concise. 2.86. What is the ratio of the Growth rate (annual %) of Bosnia and Herzegovina in 2007 to that in 2013?
Your answer should be very brief. 2.61. What is the ratio of the Growth rate (annual %) in Ghana in 2007 to that in 2013?
Provide a succinct answer. 1.89. What is the ratio of the Growth rate (annual %) in Armenia in 2008 to that in 2009?
Make the answer very short. 0.16. What is the ratio of the Growth rate (annual %) of Bosnia and Herzegovina in 2008 to that in 2009?
Offer a terse response. 1.92. What is the ratio of the Growth rate (annual %) in Ghana in 2008 to that in 2009?
Ensure brevity in your answer.  1.58. What is the ratio of the Growth rate (annual %) in Armenia in 2008 to that in 2010?
Your answer should be compact. 0.2. What is the ratio of the Growth rate (annual %) in Bosnia and Herzegovina in 2008 to that in 2010?
Make the answer very short. 0.57. What is the ratio of the Growth rate (annual %) of Ghana in 2008 to that in 2010?
Keep it short and to the point. 1.23. What is the ratio of the Growth rate (annual %) of Armenia in 2008 to that in 2011?
Offer a terse response. 0.1. What is the ratio of the Growth rate (annual %) in Bosnia and Herzegovina in 2008 to that in 2011?
Give a very brief answer. 0.71. What is the ratio of the Growth rate (annual %) in Ghana in 2008 to that in 2011?
Provide a succinct answer. 1.15. What is the ratio of the Growth rate (annual %) in Armenia in 2008 to that in 2012?
Offer a very short reply. 0.12. What is the ratio of the Growth rate (annual %) in Bosnia and Herzegovina in 2008 to that in 2012?
Keep it short and to the point. 1.2. What is the ratio of the Growth rate (annual %) in Ghana in 2008 to that in 2012?
Keep it short and to the point. 1.56. What is the ratio of the Growth rate (annual %) in Armenia in 2008 to that in 2013?
Provide a short and direct response. 0.16. What is the ratio of the Growth rate (annual %) of Bosnia and Herzegovina in 2008 to that in 2013?
Keep it short and to the point. 0.52. What is the ratio of the Growth rate (annual %) of Ghana in 2008 to that in 2013?
Your response must be concise. 2.01. What is the ratio of the Growth rate (annual %) of Armenia in 2009 to that in 2010?
Give a very brief answer. 1.28. What is the ratio of the Growth rate (annual %) in Bosnia and Herzegovina in 2009 to that in 2010?
Your answer should be very brief. 0.3. What is the ratio of the Growth rate (annual %) in Ghana in 2009 to that in 2010?
Provide a short and direct response. 0.78. What is the ratio of the Growth rate (annual %) of Armenia in 2009 to that in 2011?
Offer a terse response. 0.64. What is the ratio of the Growth rate (annual %) in Bosnia and Herzegovina in 2009 to that in 2011?
Offer a very short reply. 0.37. What is the ratio of the Growth rate (annual %) of Ghana in 2009 to that in 2011?
Offer a very short reply. 0.73. What is the ratio of the Growth rate (annual %) in Armenia in 2009 to that in 2012?
Provide a short and direct response. 0.78. What is the ratio of the Growth rate (annual %) of Bosnia and Herzegovina in 2009 to that in 2012?
Provide a short and direct response. 0.62. What is the ratio of the Growth rate (annual %) in Ghana in 2009 to that in 2012?
Ensure brevity in your answer.  0.98. What is the ratio of the Growth rate (annual %) of Armenia in 2009 to that in 2013?
Your answer should be compact. 1.02. What is the ratio of the Growth rate (annual %) in Bosnia and Herzegovina in 2009 to that in 2013?
Your answer should be very brief. 0.27. What is the ratio of the Growth rate (annual %) in Ghana in 2009 to that in 2013?
Offer a very short reply. 1.27. What is the ratio of the Growth rate (annual %) of Armenia in 2010 to that in 2011?
Make the answer very short. 0.5. What is the ratio of the Growth rate (annual %) of Bosnia and Herzegovina in 2010 to that in 2011?
Make the answer very short. 1.25. What is the ratio of the Growth rate (annual %) in Ghana in 2010 to that in 2011?
Offer a terse response. 0.94. What is the ratio of the Growth rate (annual %) of Armenia in 2010 to that in 2012?
Offer a very short reply. 0.61. What is the ratio of the Growth rate (annual %) of Bosnia and Herzegovina in 2010 to that in 2012?
Keep it short and to the point. 2.11. What is the ratio of the Growth rate (annual %) in Ghana in 2010 to that in 2012?
Keep it short and to the point. 1.27. What is the ratio of the Growth rate (annual %) in Armenia in 2010 to that in 2013?
Your response must be concise. 0.8. What is the ratio of the Growth rate (annual %) of Bosnia and Herzegovina in 2010 to that in 2013?
Make the answer very short. 0.91. What is the ratio of the Growth rate (annual %) in Ghana in 2010 to that in 2013?
Your answer should be very brief. 1.64. What is the ratio of the Growth rate (annual %) in Armenia in 2011 to that in 2012?
Offer a terse response. 1.22. What is the ratio of the Growth rate (annual %) of Bosnia and Herzegovina in 2011 to that in 2012?
Provide a succinct answer. 1.7. What is the ratio of the Growth rate (annual %) in Ghana in 2011 to that in 2012?
Offer a terse response. 1.35. What is the ratio of the Growth rate (annual %) of Armenia in 2011 to that in 2013?
Your answer should be compact. 1.6. What is the ratio of the Growth rate (annual %) in Bosnia and Herzegovina in 2011 to that in 2013?
Provide a short and direct response. 0.73. What is the ratio of the Growth rate (annual %) of Ghana in 2011 to that in 2013?
Your response must be concise. 1.74. What is the ratio of the Growth rate (annual %) in Armenia in 2012 to that in 2013?
Your response must be concise. 1.32. What is the ratio of the Growth rate (annual %) in Bosnia and Herzegovina in 2012 to that in 2013?
Give a very brief answer. 0.43. What is the ratio of the Growth rate (annual %) in Ghana in 2012 to that in 2013?
Offer a very short reply. 1.29. What is the difference between the highest and the second highest Growth rate (annual %) of Armenia?
Offer a very short reply. 9.45. What is the difference between the highest and the second highest Growth rate (annual %) in Bosnia and Herzegovina?
Make the answer very short. 3.47. What is the difference between the highest and the second highest Growth rate (annual %) of Ghana?
Offer a very short reply. 0.16. What is the difference between the highest and the lowest Growth rate (annual %) in Armenia?
Your answer should be compact. 39.95. What is the difference between the highest and the lowest Growth rate (annual %) in Bosnia and Herzegovina?
Offer a very short reply. 22.07. What is the difference between the highest and the lowest Growth rate (annual %) in Ghana?
Offer a very short reply. 19.84. 